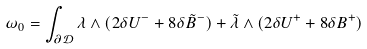<formula> <loc_0><loc_0><loc_500><loc_500>\omega _ { 0 } = \int _ { \partial \mathcal { D } } \lambda \wedge ( 2 \delta U ^ { - } + 8 \delta \tilde { B } ^ { - } ) + \tilde { \lambda } \wedge ( 2 \delta U ^ { + } + 8 \delta B ^ { + } )</formula> 